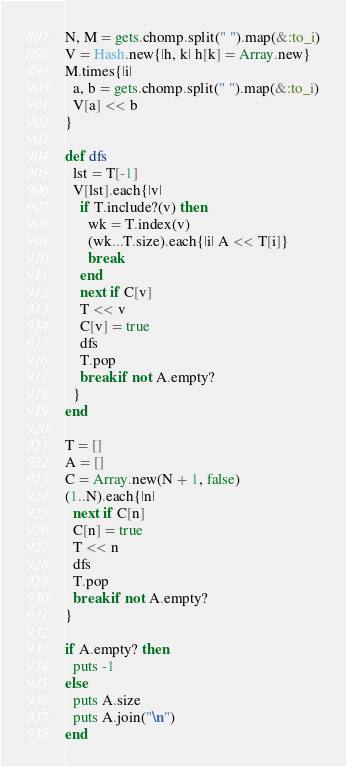<code> <loc_0><loc_0><loc_500><loc_500><_Ruby_>N, M = gets.chomp.split(" ").map(&:to_i)
V = Hash.new{|h, k| h[k] = Array.new}
M.times{|i|
  a, b = gets.chomp.split(" ").map(&:to_i)
  V[a] << b
}

def dfs
  lst = T[-1]
  V[lst].each{|v|
    if T.include?(v) then
      wk = T.index(v)
      (wk...T.size).each{|i| A << T[i]}
      break
    end
    next if C[v]
    T << v
    C[v] = true
    dfs
    T.pop
    break if not A.empty?
  }
end

T = []
A = []
C = Array.new(N + 1, false)
(1..N).each{|n|
  next if C[n]
  C[n] = true
  T << n
  dfs
  T.pop
  break if not A.empty?
}

if A.empty? then
  puts -1
else
  puts A.size
  puts A.join("\n")
end
</code> 